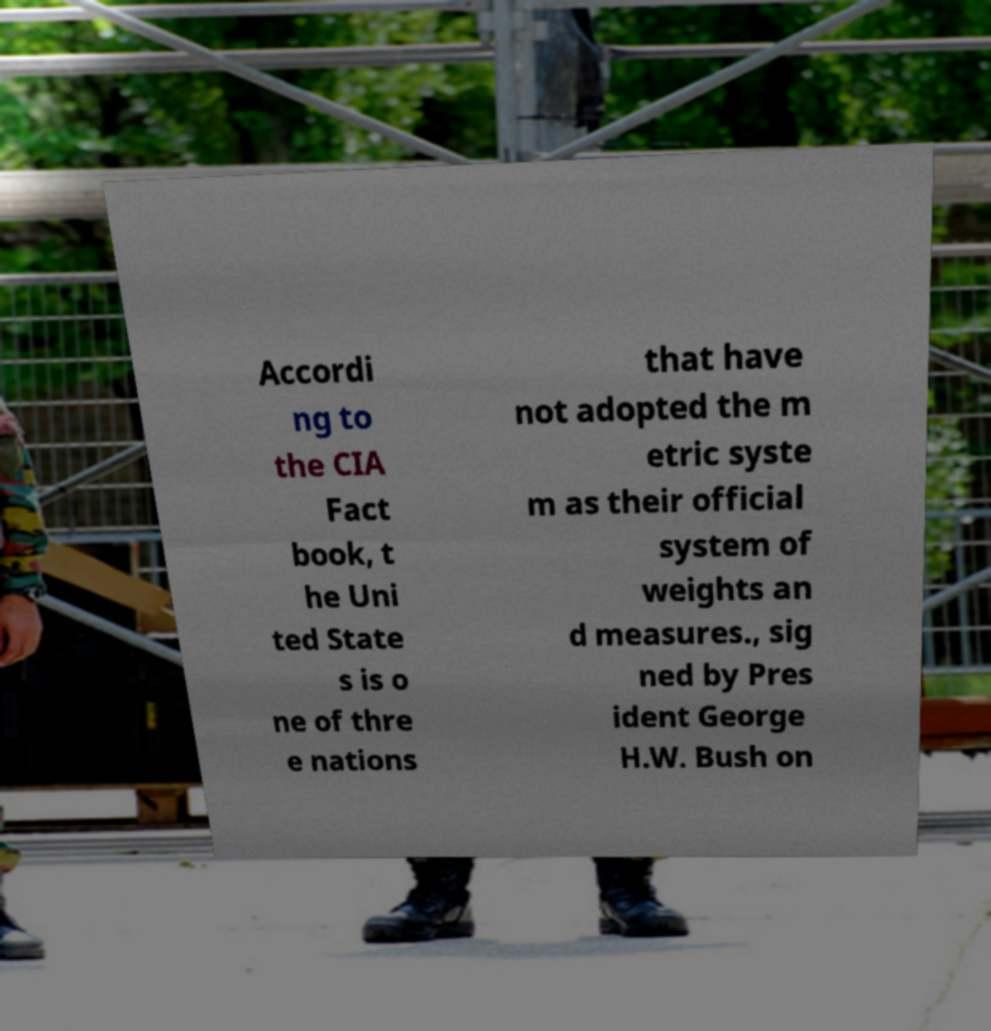Please identify and transcribe the text found in this image. Accordi ng to the CIA Fact book, t he Uni ted State s is o ne of thre e nations that have not adopted the m etric syste m as their official system of weights an d measures., sig ned by Pres ident George H.W. Bush on 